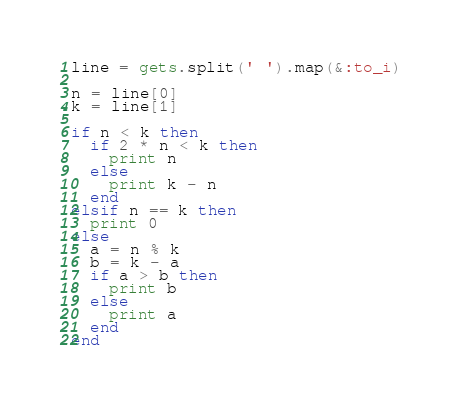<code> <loc_0><loc_0><loc_500><loc_500><_Ruby_>line = gets.split(' ').map(&:to_i)

n = line[0]
k = line[1]

if n < k then
  if 2 * n < k then
    print n
  else
    print k - n
  end
elsif n == k then
  print 0
else
  a = n % k
  b = k - a
  if a > b then
    print b
  else
    print a
  end
end</code> 